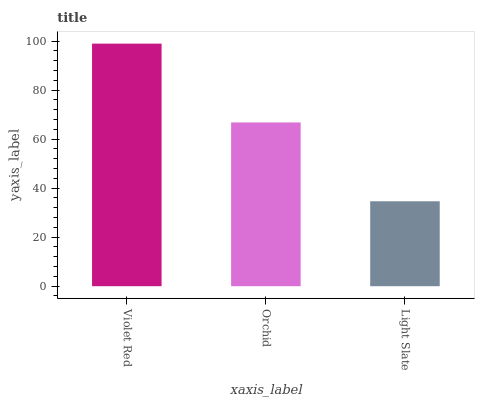Is Light Slate the minimum?
Answer yes or no. Yes. Is Violet Red the maximum?
Answer yes or no. Yes. Is Orchid the minimum?
Answer yes or no. No. Is Orchid the maximum?
Answer yes or no. No. Is Violet Red greater than Orchid?
Answer yes or no. Yes. Is Orchid less than Violet Red?
Answer yes or no. Yes. Is Orchid greater than Violet Red?
Answer yes or no. No. Is Violet Red less than Orchid?
Answer yes or no. No. Is Orchid the high median?
Answer yes or no. Yes. Is Orchid the low median?
Answer yes or no. Yes. Is Light Slate the high median?
Answer yes or no. No. Is Light Slate the low median?
Answer yes or no. No. 